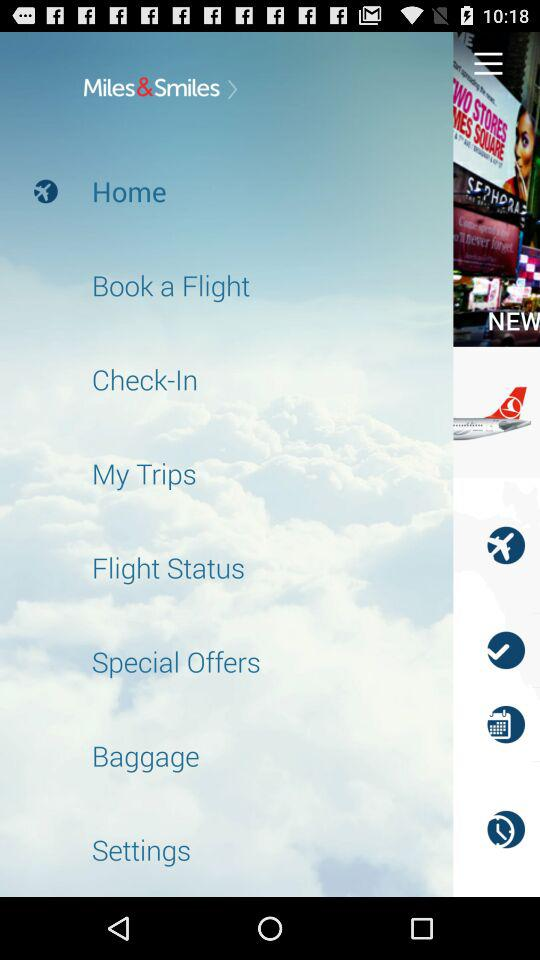What is the name of the application?
When the provided information is insufficient, respond with <no answer>. <no answer> 